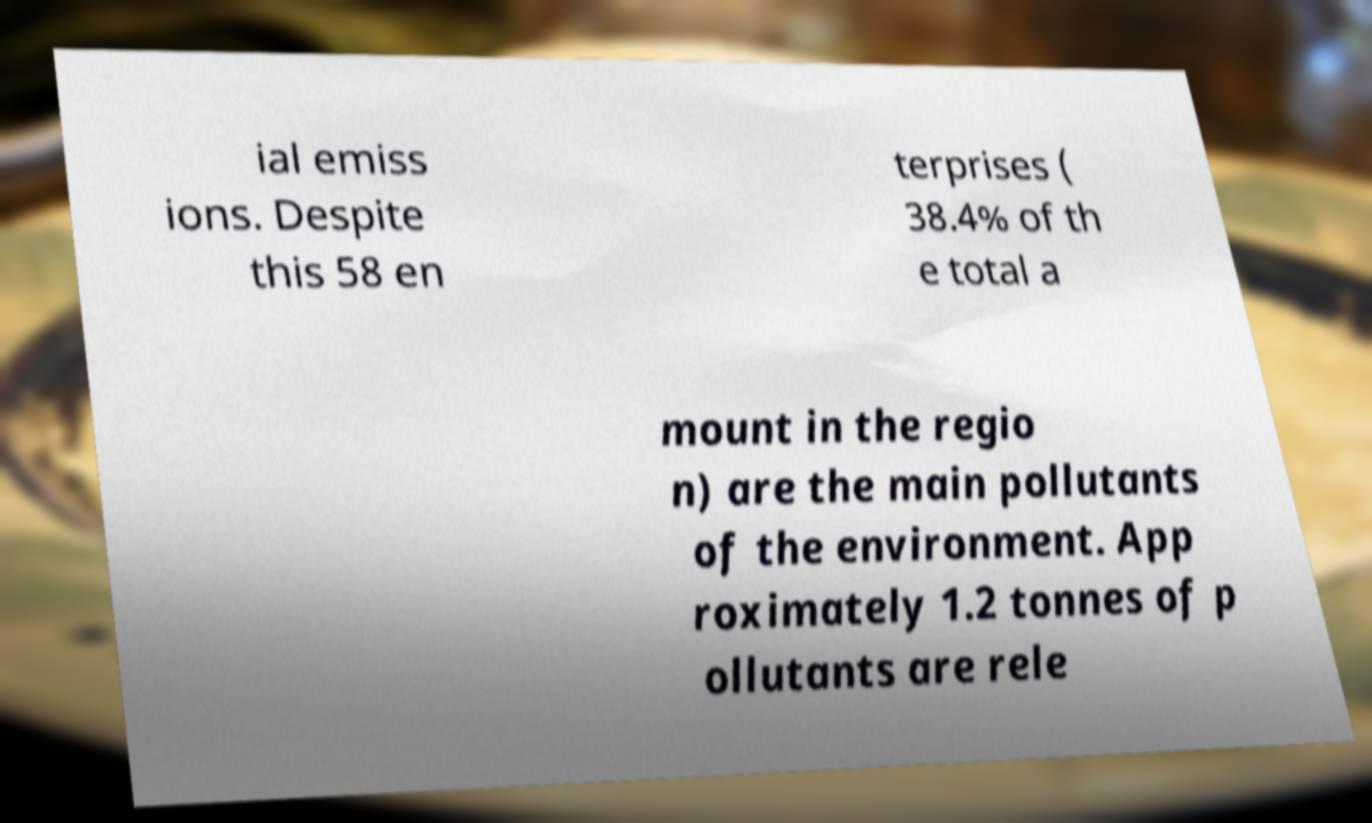For documentation purposes, I need the text within this image transcribed. Could you provide that? ial emiss ions. Despite this 58 en terprises ( 38.4% of th e total a mount in the regio n) are the main pollutants of the environment. App roximately 1.2 tonnes of p ollutants are rele 